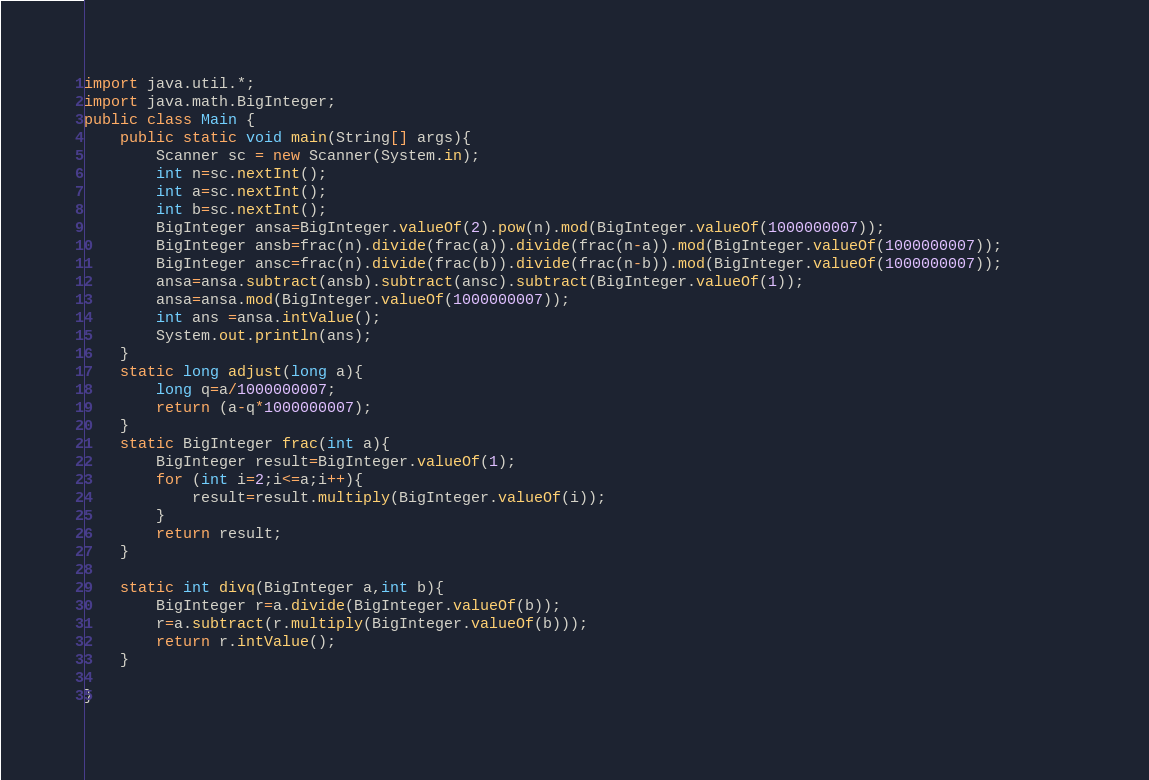Convert code to text. <code><loc_0><loc_0><loc_500><loc_500><_Java_>import java.util.*;
import java.math.BigInteger;
public class Main {
    public static void main(String[] args){
        Scanner sc = new Scanner(System.in);
        int n=sc.nextInt();
        int a=sc.nextInt();
        int b=sc.nextInt();
        BigInteger ansa=BigInteger.valueOf(2).pow(n).mod(BigInteger.valueOf(1000000007));
        BigInteger ansb=frac(n).divide(frac(a)).divide(frac(n-a)).mod(BigInteger.valueOf(1000000007));
        BigInteger ansc=frac(n).divide(frac(b)).divide(frac(n-b)).mod(BigInteger.valueOf(1000000007));        
        ansa=ansa.subtract(ansb).subtract(ansc).subtract(BigInteger.valueOf(1));
        ansa=ansa.mod(BigInteger.valueOf(1000000007));
        int ans =ansa.intValue();
        System.out.println(ans);
    }
    static long adjust(long a){
        long q=a/1000000007;
        return (a-q*1000000007);
    }
    static BigInteger frac(int a){
        BigInteger result=BigInteger.valueOf(1);
        for (int i=2;i<=a;i++){
            result=result.multiply(BigInteger.valueOf(i));
        }
        return result;
    }

    static int divq(BigInteger a,int b){
        BigInteger r=a.divide(BigInteger.valueOf(b));
        r=a.subtract(r.multiply(BigInteger.valueOf(b)));
        return r.intValue();
    }

}</code> 